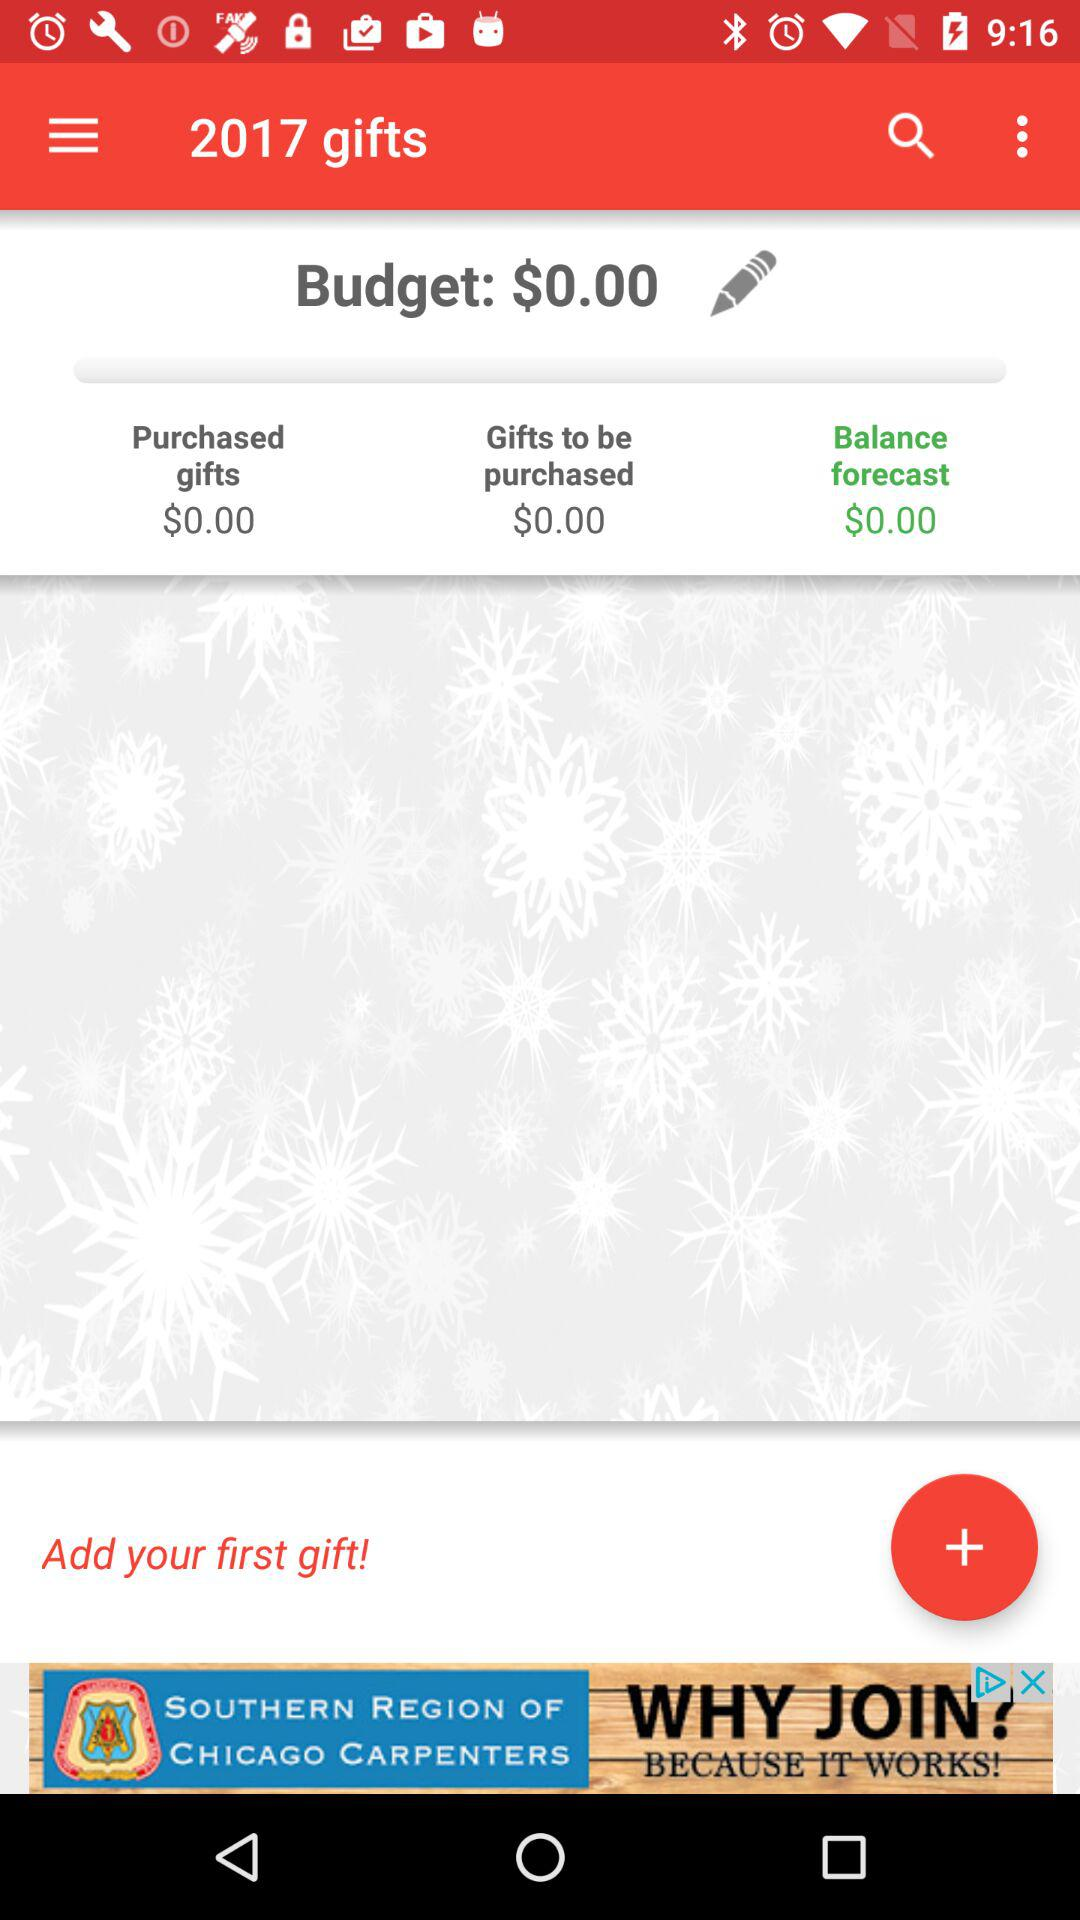What is the budget price? The budget price is $0. 